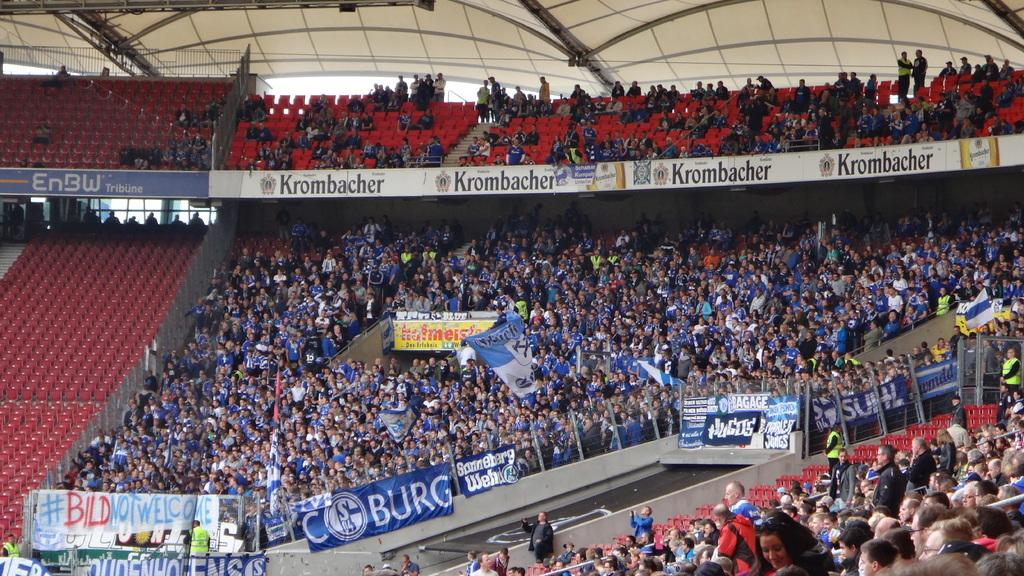What type of venue is shown in the image? The image depicts a stadium. What can be seen inside the stadium? There is a crowd in the stadium. Are there any signs or displays visible in the stadium? Yes, there are banners and boards visible in the stadium. What is the structure of the stadium like? The stadium has a roof at the top. How does the pollution affect the view from the stadium? The image does not show any pollution, and therefore it cannot affect the view from the stadium. 